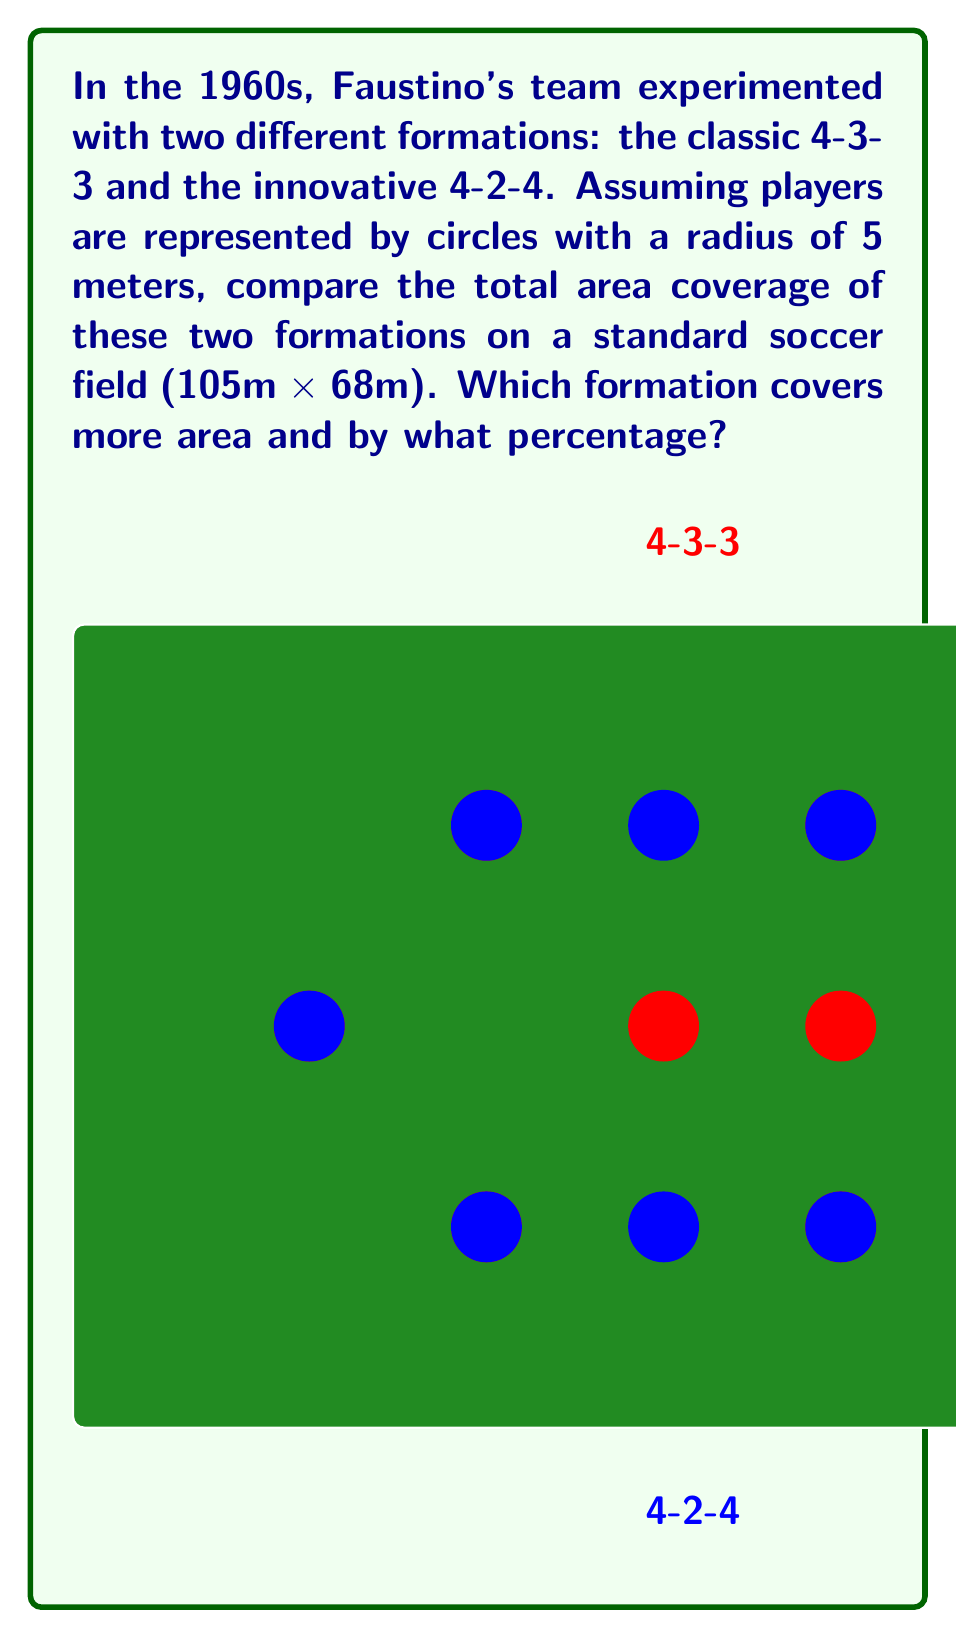Could you help me with this problem? Let's approach this step-by-step:

1) Area of a single player:
   The area covered by each player is a circle with radius 5m.
   Area = $\pi r^2 = \pi (5)^2 = 25\pi$ square meters

2) Total area covered by each formation:
   Both formations have 10 outfield players (excluding the goalkeeper).
   Total area = $10 * 25\pi = 250\pi$ square meters

3) However, we need to account for overlapping areas. The 4-3-3 formation typically has more compact positioning, leading to more overlap. Let's estimate that the effective coverage is reduced by 15% for 4-3-3 and 10% for 4-2-4 due to overlaps.

   4-3-3 effective coverage: $250\pi * 0.85 = 212.5\pi$ square meters
   4-2-4 effective coverage: $250\pi * 0.90 = 225\pi$ square meters

4) To calculate the percentage difference:
   $$\text{Percentage Difference} = \frac{\text{Difference}}{\text{Average}} * 100\%$$
   $$= \frac{(225\pi - 212.5\pi)}{(225\pi + 212.5\pi)/2} * 100\%$$
   $$= \frac{12.5\pi}{218.75\pi} * 100\% \approx 5.71\%$$

5) The 4-2-4 formation covers approximately 5.71% more area than the 4-3-3 formation.
Answer: 4-2-4 covers 5.71% more area 